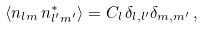Convert formula to latex. <formula><loc_0><loc_0><loc_500><loc_500>\langle n _ { l m } \, n ^ { * } _ { l ^ { \prime } m ^ { \prime } } \rangle = C _ { l } \, \delta _ { l , l ^ { \prime } } \delta _ { m , m ^ { \prime } } \, ,</formula> 